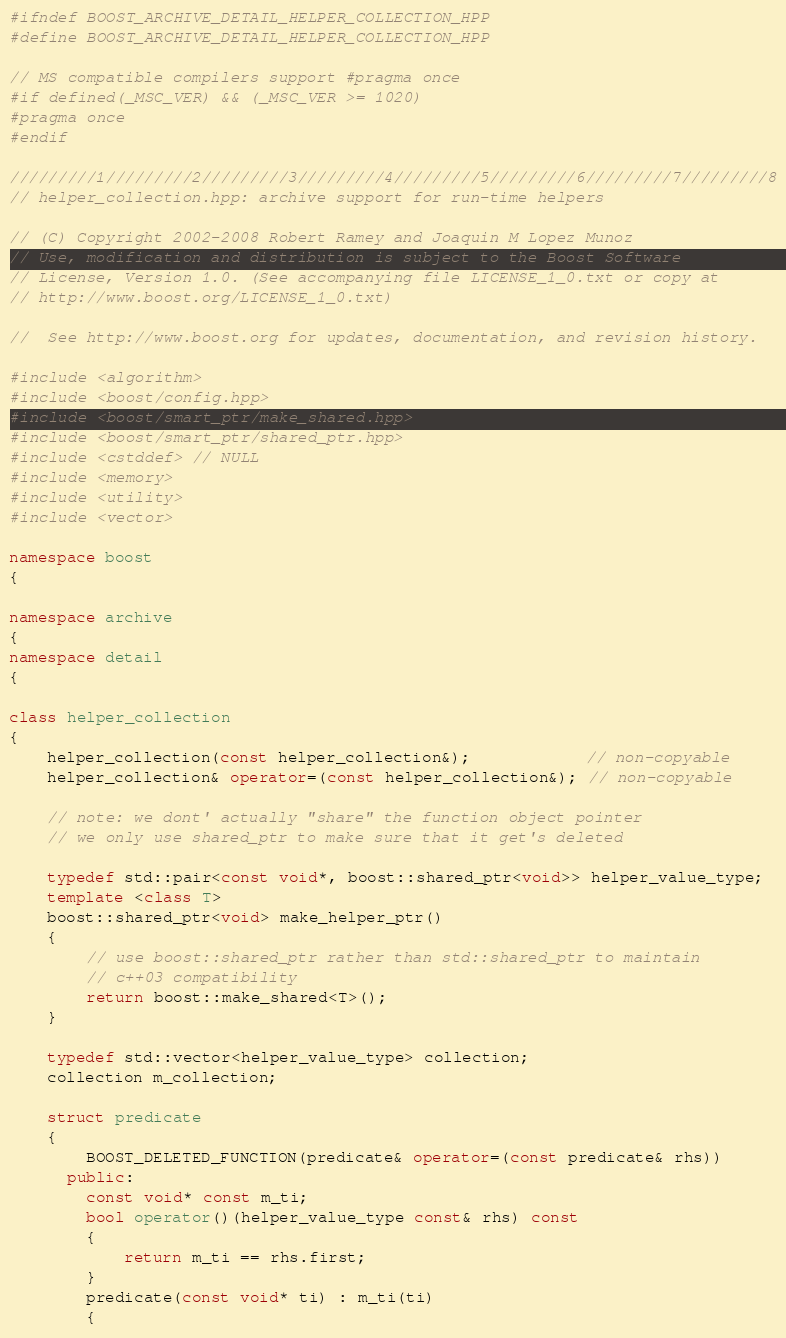<code> <loc_0><loc_0><loc_500><loc_500><_C++_>#ifndef BOOST_ARCHIVE_DETAIL_HELPER_COLLECTION_HPP
#define BOOST_ARCHIVE_DETAIL_HELPER_COLLECTION_HPP

// MS compatible compilers support #pragma once
#if defined(_MSC_VER) && (_MSC_VER >= 1020)
#pragma once
#endif

/////////1/////////2/////////3/////////4/////////5/////////6/////////7/////////8
// helper_collection.hpp: archive support for run-time helpers

// (C) Copyright 2002-2008 Robert Ramey and Joaquin M Lopez Munoz
// Use, modification and distribution is subject to the Boost Software
// License, Version 1.0. (See accompanying file LICENSE_1_0.txt or copy at
// http://www.boost.org/LICENSE_1_0.txt)

//  See http://www.boost.org for updates, documentation, and revision history.

#include <algorithm>
#include <boost/config.hpp>
#include <boost/smart_ptr/make_shared.hpp>
#include <boost/smart_ptr/shared_ptr.hpp>
#include <cstddef> // NULL
#include <memory>
#include <utility>
#include <vector>

namespace boost
{

namespace archive
{
namespace detail
{

class helper_collection
{
    helper_collection(const helper_collection&);            // non-copyable
    helper_collection& operator=(const helper_collection&); // non-copyable

    // note: we dont' actually "share" the function object pointer
    // we only use shared_ptr to make sure that it get's deleted

    typedef std::pair<const void*, boost::shared_ptr<void>> helper_value_type;
    template <class T>
    boost::shared_ptr<void> make_helper_ptr()
    {
        // use boost::shared_ptr rather than std::shared_ptr to maintain
        // c++03 compatibility
        return boost::make_shared<T>();
    }

    typedef std::vector<helper_value_type> collection;
    collection m_collection;

    struct predicate
    {
        BOOST_DELETED_FUNCTION(predicate& operator=(const predicate& rhs))
      public:
        const void* const m_ti;
        bool operator()(helper_value_type const& rhs) const
        {
            return m_ti == rhs.first;
        }
        predicate(const void* ti) : m_ti(ti)
        {</code> 